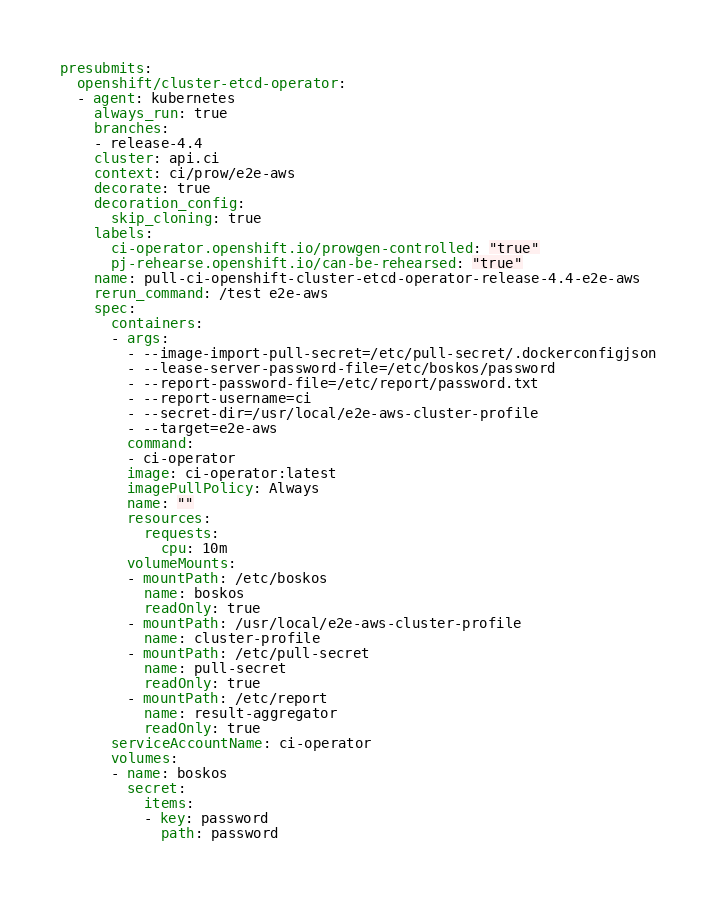<code> <loc_0><loc_0><loc_500><loc_500><_YAML_>presubmits:
  openshift/cluster-etcd-operator:
  - agent: kubernetes
    always_run: true
    branches:
    - release-4.4
    cluster: api.ci
    context: ci/prow/e2e-aws
    decorate: true
    decoration_config:
      skip_cloning: true
    labels:
      ci-operator.openshift.io/prowgen-controlled: "true"
      pj-rehearse.openshift.io/can-be-rehearsed: "true"
    name: pull-ci-openshift-cluster-etcd-operator-release-4.4-e2e-aws
    rerun_command: /test e2e-aws
    spec:
      containers:
      - args:
        - --image-import-pull-secret=/etc/pull-secret/.dockerconfigjson
        - --lease-server-password-file=/etc/boskos/password
        - --report-password-file=/etc/report/password.txt
        - --report-username=ci
        - --secret-dir=/usr/local/e2e-aws-cluster-profile
        - --target=e2e-aws
        command:
        - ci-operator
        image: ci-operator:latest
        imagePullPolicy: Always
        name: ""
        resources:
          requests:
            cpu: 10m
        volumeMounts:
        - mountPath: /etc/boskos
          name: boskos
          readOnly: true
        - mountPath: /usr/local/e2e-aws-cluster-profile
          name: cluster-profile
        - mountPath: /etc/pull-secret
          name: pull-secret
          readOnly: true
        - mountPath: /etc/report
          name: result-aggregator
          readOnly: true
      serviceAccountName: ci-operator
      volumes:
      - name: boskos
        secret:
          items:
          - key: password
            path: password</code> 